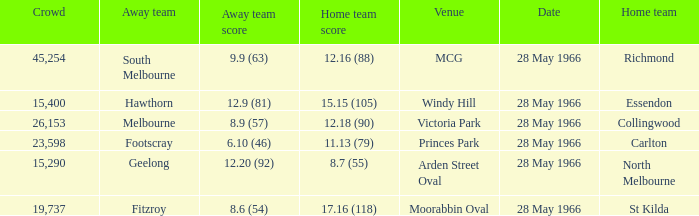Which Crowd has a Home team of richmond? 45254.0. 